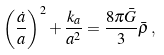<formula> <loc_0><loc_0><loc_500><loc_500>\left ( \frac { \dot { a } } { a } \right ) ^ { 2 } + \frac { k _ { a } } { a ^ { 2 } } = \frac { 8 \pi \bar { G } } { 3 } \bar { \rho } \, ,</formula> 